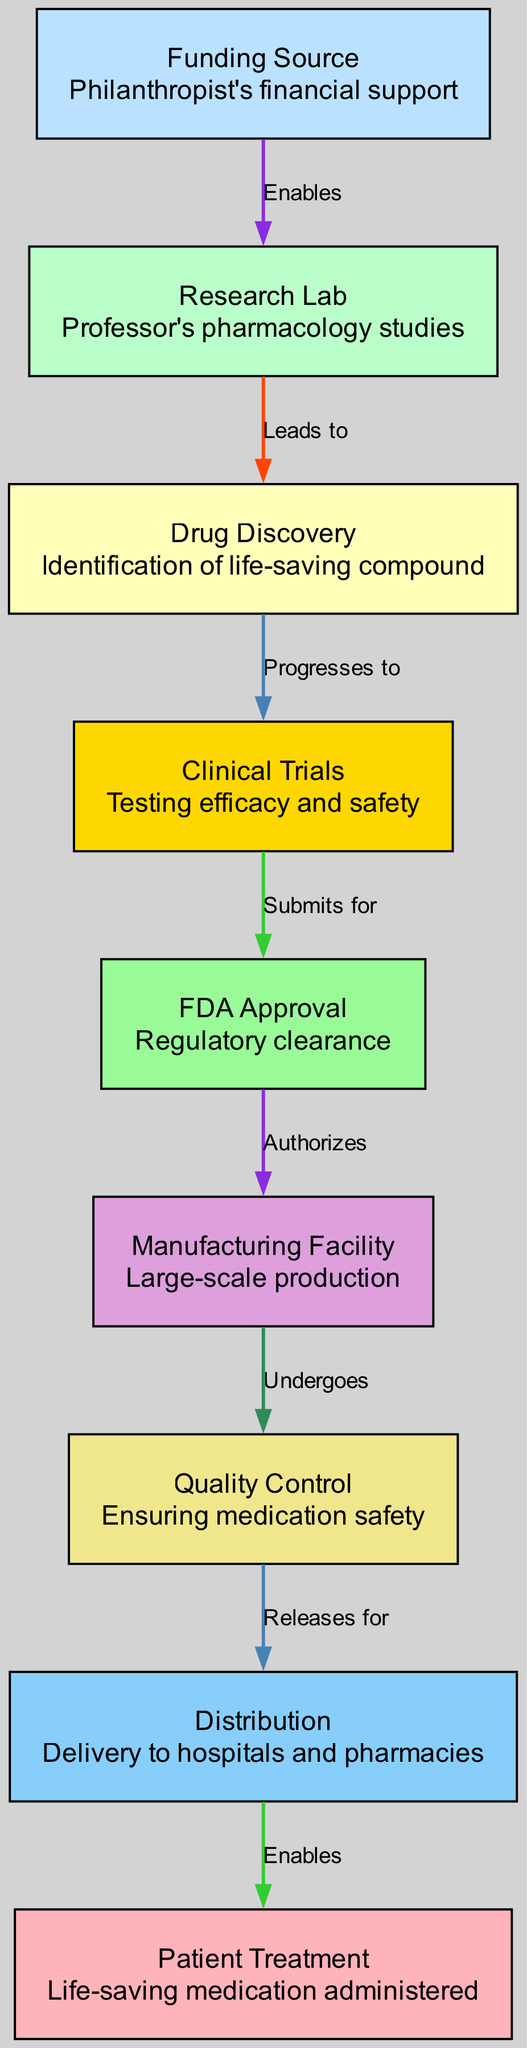What node follows the Research Lab? According to the diagram, the Research Lab (node 1) leads to the Drug Discovery (node 3) as indicated by the label "Leads to."
Answer: Drug Discovery How many nodes are in the diagram? The diagram contains a total of 9 nodes, which can be counted directly from the nodes list provided.
Answer: 9 What is the role of the Funding Source in the process? The Funding Source (node 2) enables the activities in the Research Lab (node 1), as shown by the edge labeled "Enables."
Answer: Enables research What happens after Clinical Trials? After Clinical Trials (node 4), the process submits for FDA Approval (node 5), indicated by the edge labeled "Submits for."
Answer: FDA Approval Which node is responsible for Quality Control? The Quality Control node (node 7) is a distinct step in the manufacturing process that ensures the medication's safety and quality. It follows the Manufacturing Facility (node 6).
Answer: Quality Control What connects the Manufacturing Facility to Distribution? The Manufacturing Facility (node 6) undergoes Quality Control (node 7), which then releases the medication for Distribution (node 8), as per the labeled edge "Releases for."
Answer: Quality Control What indicates the completion of the medication's journey? The final node is Patient Treatment (node 9), which is enabled by the Distribution node (node 8) through the edge labeled "Enables." This indicates the completion of the medication's journey to the patient.
Answer: Patient Treatment Which two nodes are directly linked by the edge labeled "Authorizes"? The nodes directly linked by the edge labeled "Authorizes" are FDA Approval (node 5) and Manufacturing Facility (node 6), showing the regulatory step before production.
Answer: FDA Approval and Manufacturing Facility What step follows Drug Discovery in the diagram? After Drug Discovery (node 3), the next step is Clinical Trials (node 4), as indicated by the edge labeled "Progresses to."
Answer: Clinical Trials 